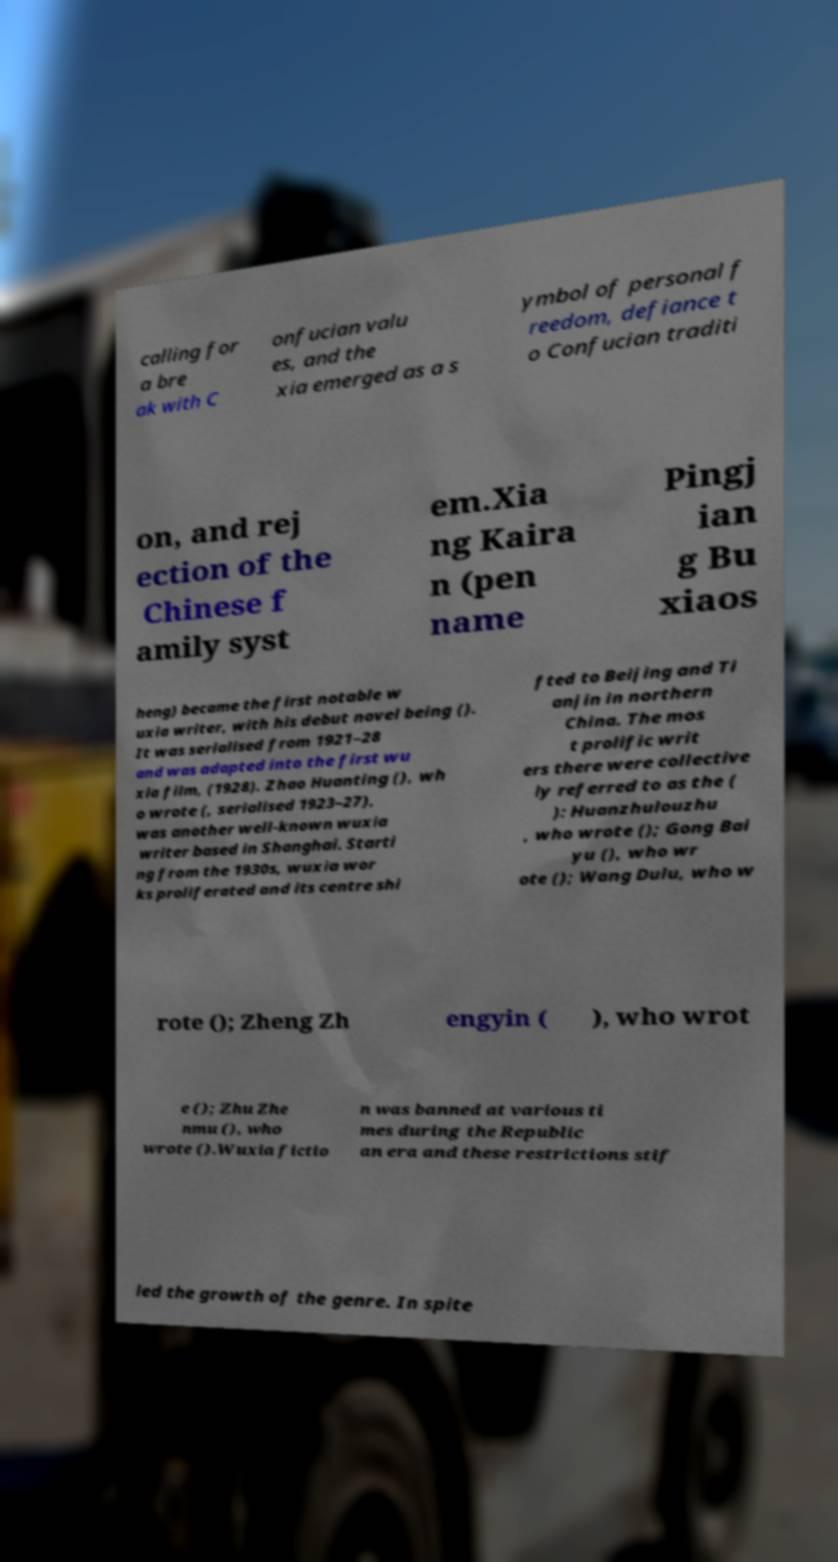Can you accurately transcribe the text from the provided image for me? calling for a bre ak with C onfucian valu es, and the xia emerged as a s ymbol of personal f reedom, defiance t o Confucian traditi on, and rej ection of the Chinese f amily syst em.Xia ng Kaira n (pen name Pingj ian g Bu xiaos heng) became the first notable w uxia writer, with his debut novel being (). It was serialised from 1921–28 and was adapted into the first wu xia film, (1928). Zhao Huanting (), wh o wrote (, serialised 1923–27), was another well-known wuxia writer based in Shanghai. Starti ng from the 1930s, wuxia wor ks proliferated and its centre shi fted to Beijing and Ti anjin in northern China. The mos t prolific writ ers there were collective ly referred to as the ( ): Huanzhulouzhu , who wrote (); Gong Bai yu (), who wr ote (); Wang Dulu, who w rote (); Zheng Zh engyin ( ), who wrot e (); Zhu Zhe nmu (), who wrote ().Wuxia fictio n was banned at various ti mes during the Republic an era and these restrictions stif led the growth of the genre. In spite 